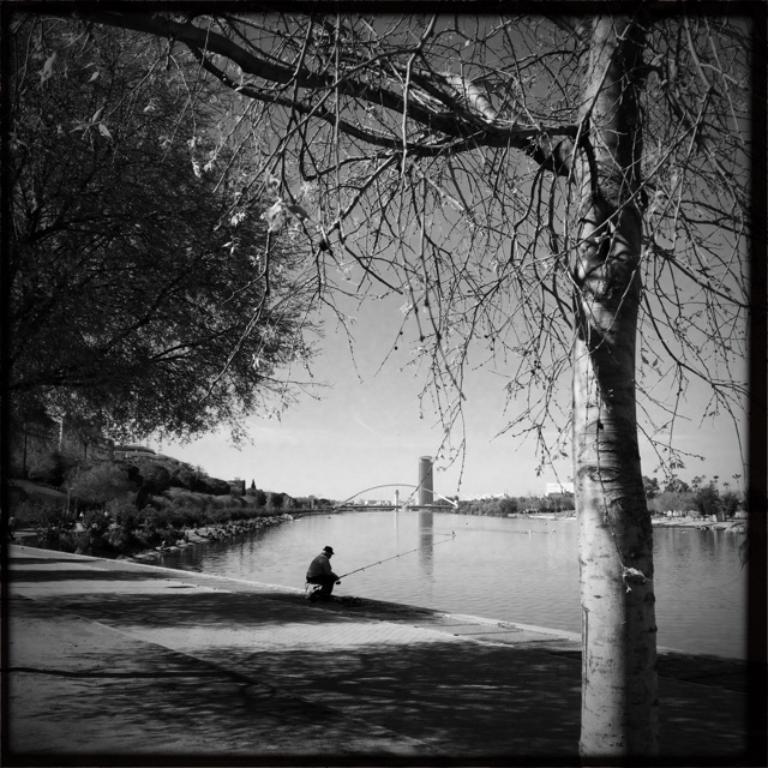Can you describe this image briefly? Black and white picture. In this picture we can see a person, trees, water and sky. Far there is a bridge and tower. 